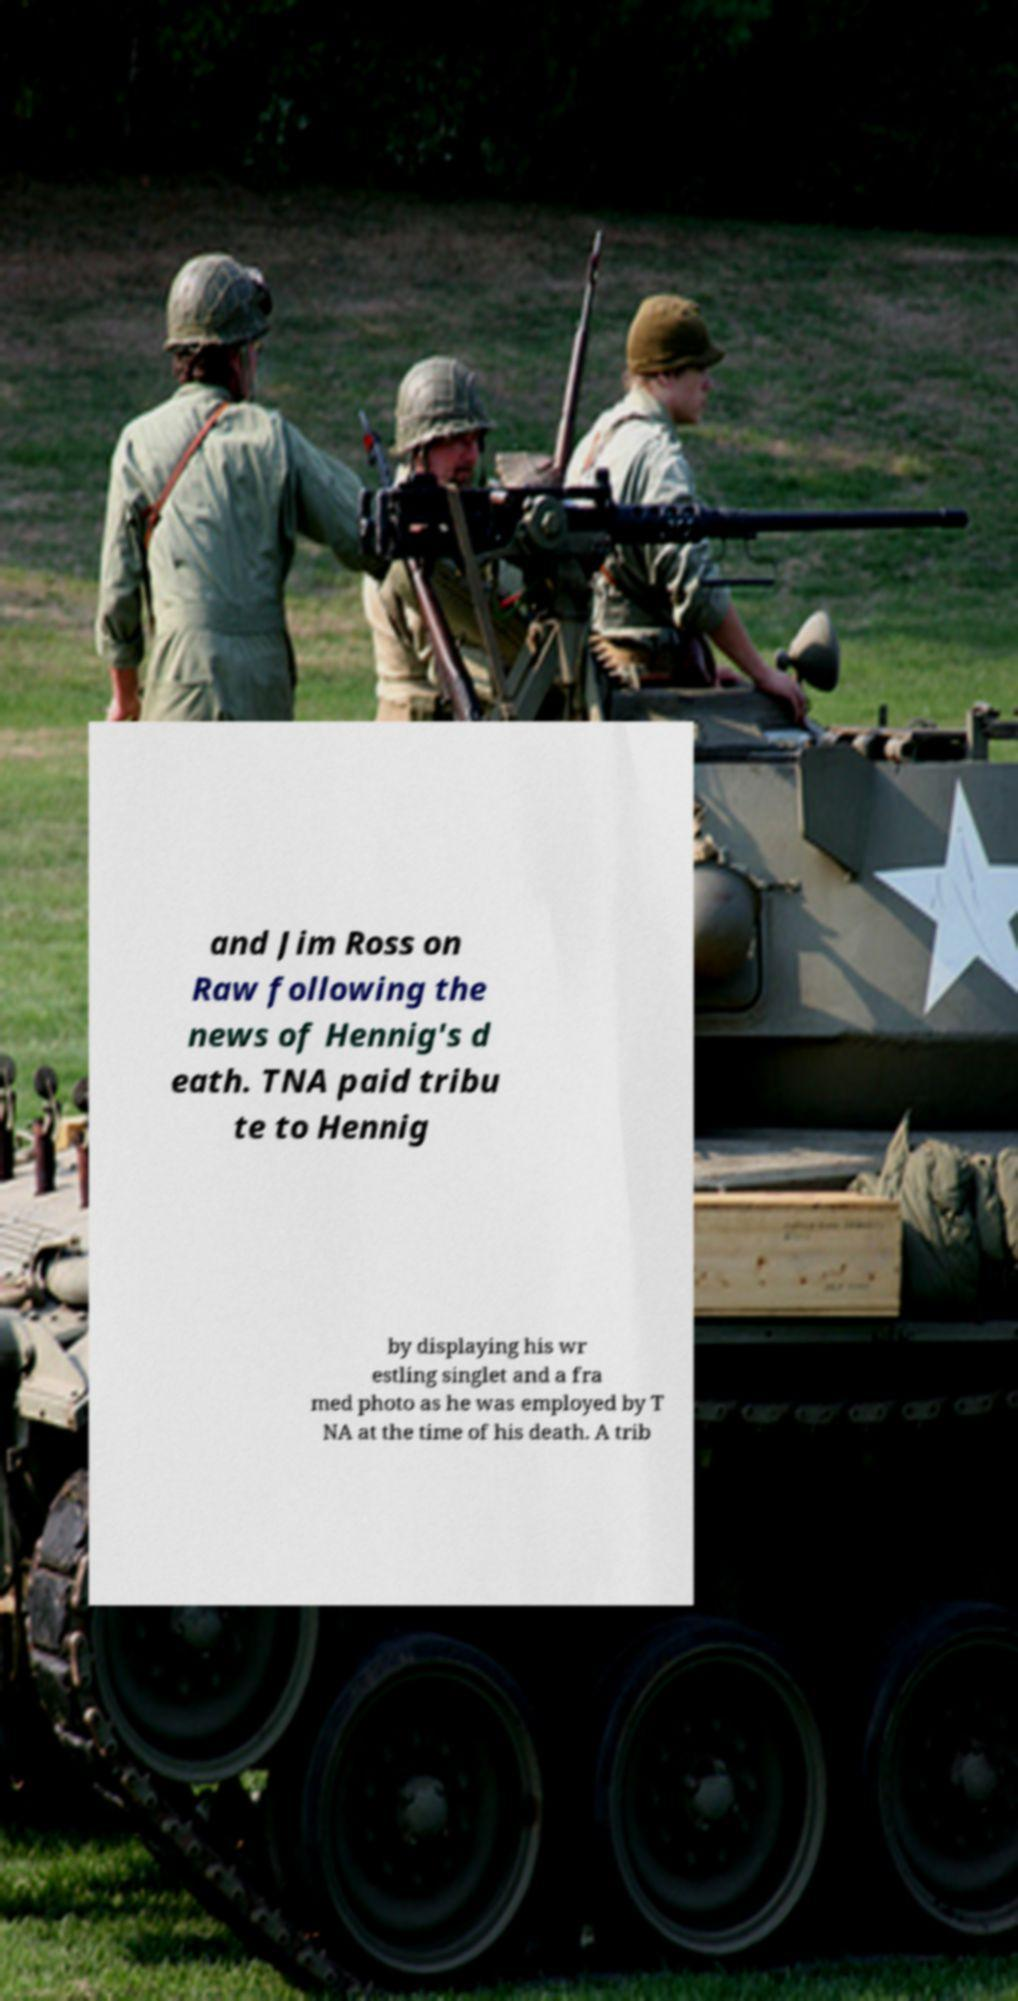I need the written content from this picture converted into text. Can you do that? and Jim Ross on Raw following the news of Hennig's d eath. TNA paid tribu te to Hennig by displaying his wr estling singlet and a fra med photo as he was employed by T NA at the time of his death. A trib 